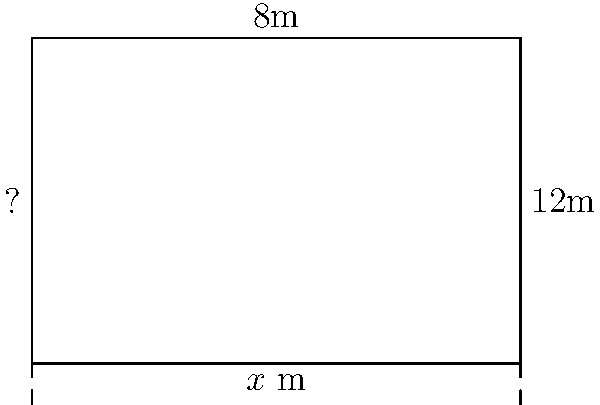Your garden plot is rectangular in shape. The width is 8 meters, and the length is $x$ meters. If the perimeter of the garden is 40 meters, what is the length of the garden? Let's solve this step by step:

1) First, we need to recall the formula for the perimeter of a rectangle:
   Perimeter = 2 × (length + width)

2) We know the perimeter is 40 meters and the width is 8 meters. Let's substitute these into our formula:
   40 = 2 × ($x$ + 8)

3) Now, let's solve this equation for $x$:
   40 = 2$x$ + 16

4) Subtract 16 from both sides:
   24 = 2$x$

5) Divide both sides by 2:
   12 = $x$

Therefore, the length of the garden is 12 meters.

To verify:
Perimeter = 2 × (12 + 8) = 2 × 20 = 40 meters, which matches our given information.
Answer: 12 meters 